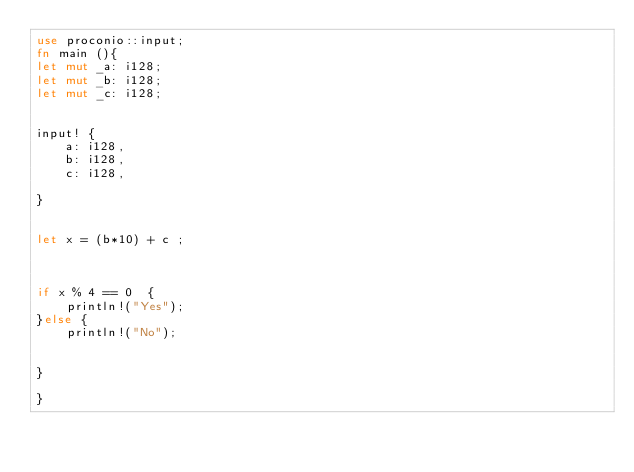<code> <loc_0><loc_0><loc_500><loc_500><_Rust_>use proconio::input;
fn main (){
let mut _a: i128;
let mut _b: i128;
let mut _c: i128;


input! {
    a: i128,
    b: i128,
    c: i128,

}
 

let x = (b*10) + c ;



if x % 4 == 0  {
    println!("Yes");
}else {
    println!("No");


}
 
}
</code> 